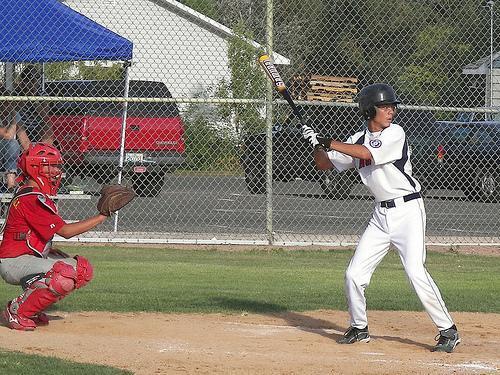How many players are on the field?
Give a very brief answer. 2. How many vehicles are in the background?
Give a very brief answer. 3. 